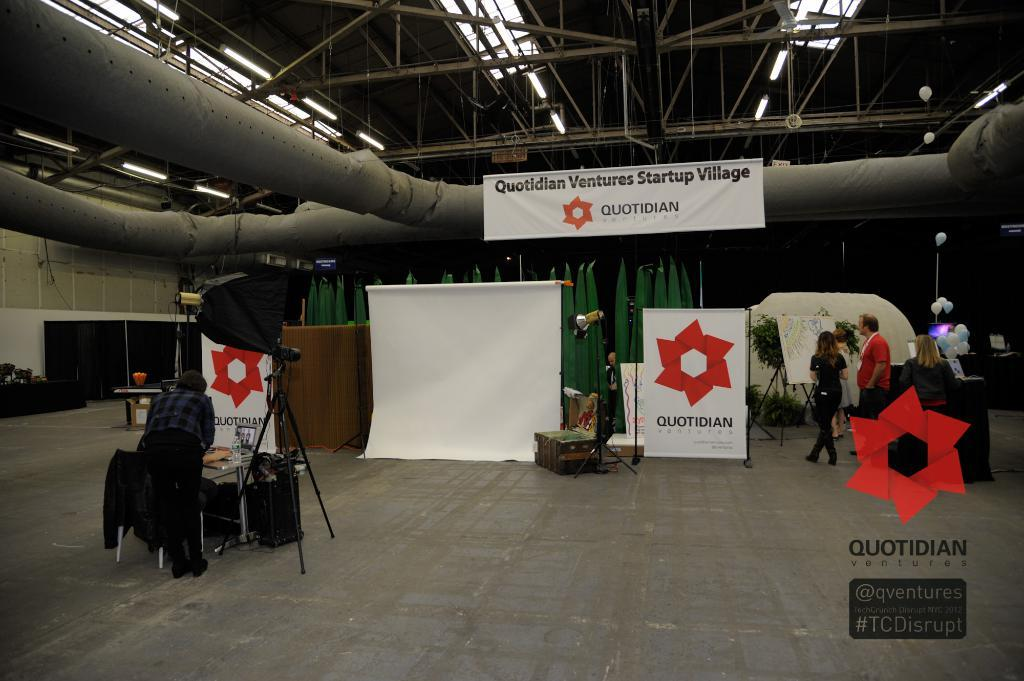<image>
Summarize the visual content of the image. a sign in a building that says 'quotidian ventures startup' on it 